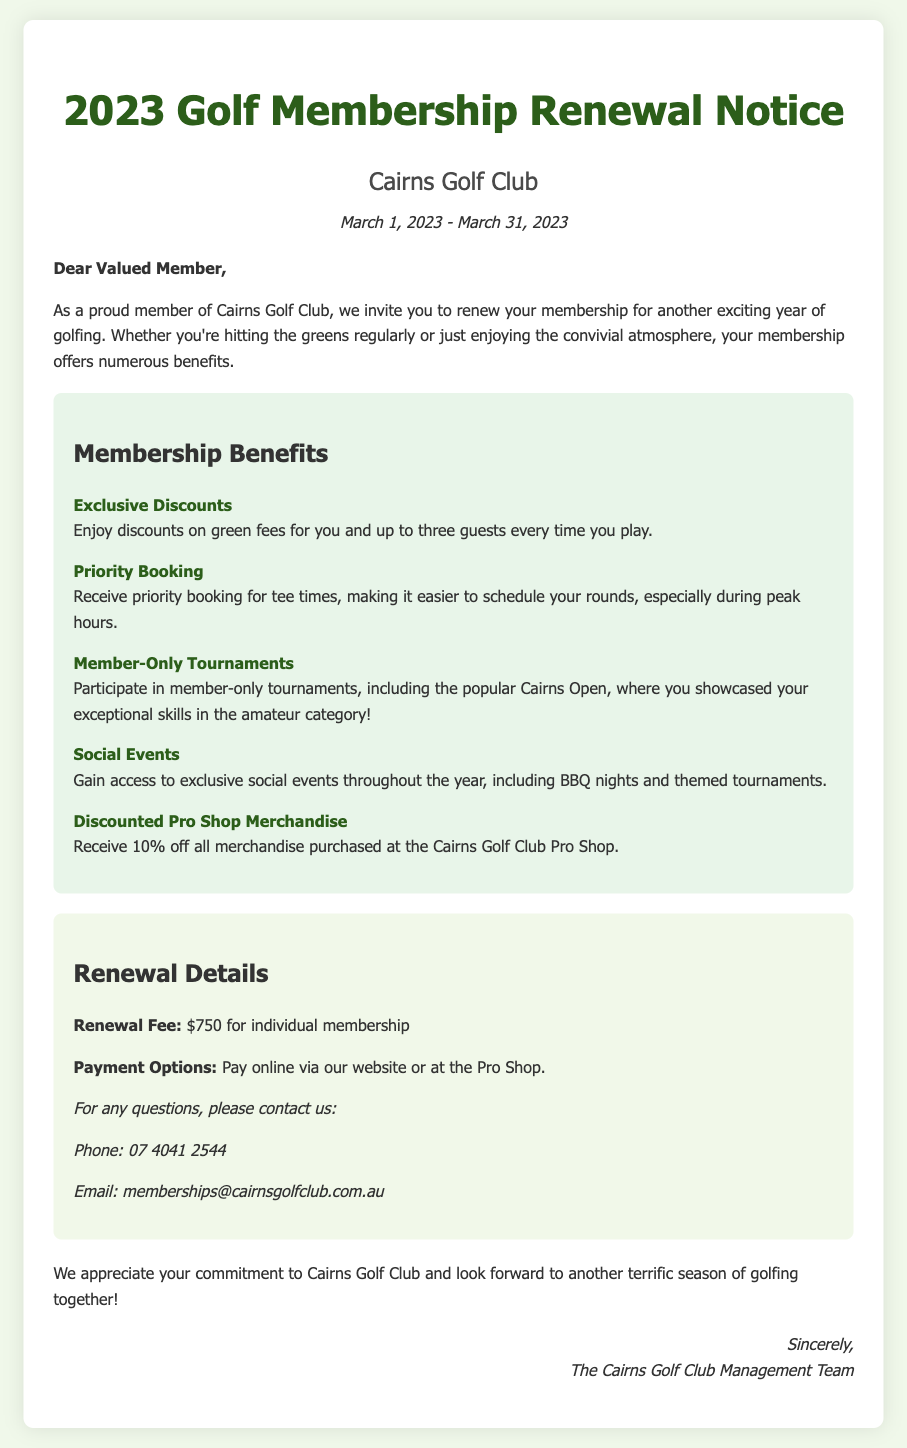What is the renewal fee for individual membership? The renewal fee for individual membership is clearly stated in the renewal details section of the document.
Answer: $750 What is the contact email for membership inquiries? The document provides a specific email contact for any membership-related questions, making it easy to find.
Answer: memberships@cairnsgolfclub.com.au What is one of the social events mentioned for members? The document lists various social events, specifically highlighting one as an example.
Answer: BBQ nights During what period can members renew their membership? The renewal period is explicitly stated at the top of the document, indicating when members should complete the renewal.
Answer: March 1, 2023 - March 31, 2023 How much discount do members receive on Pro Shop merchandise? The document specifies the discount available to members for Pro Shop purchases, making it straightforward to find.
Answer: 10% What is one benefit of membership related to playtime? The document describes various benefits, including one specifically about scheduling tee times for members.
Answer: Priority Booking What type of tournaments can members participate in? The document indicates that members have the opportunity to participate in specific tournaments, noting one explicitly.
Answer: Member-Only Tournaments What is the main purpose of this document? The intent of the document is clear based on its title and opening statements, summarizing its primary function.
Answer: Membership Renewal Notice 